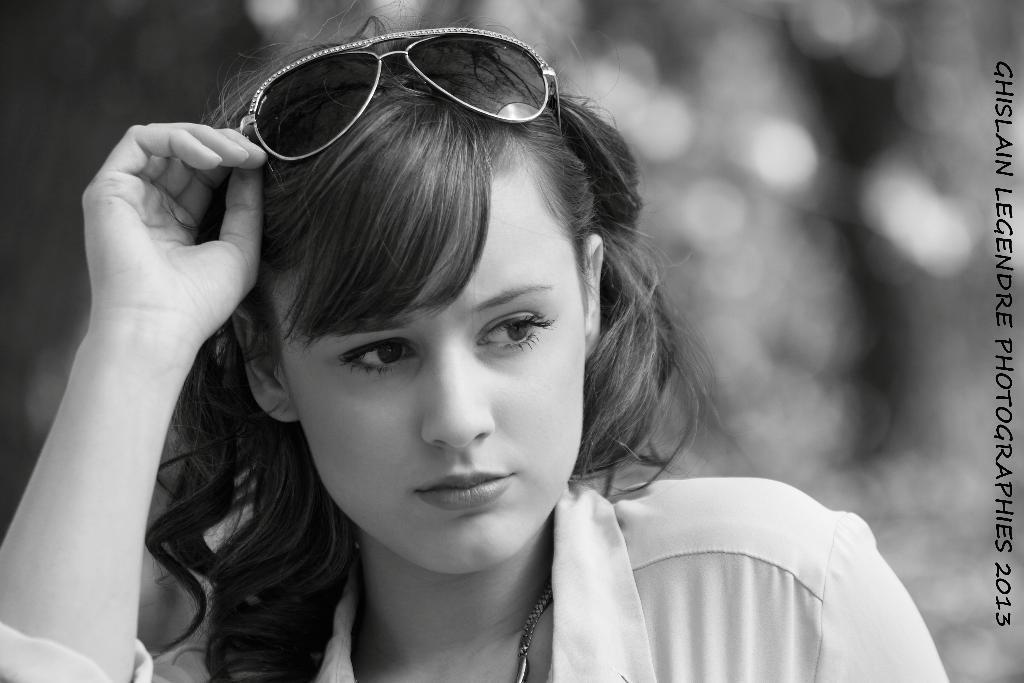Could you give a brief overview of what you see in this image? In this picture I can see a person with spectacles, and there is blur background and a watermark on the image. 